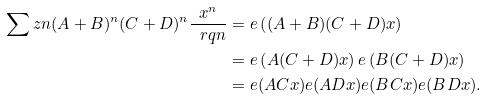<formula> <loc_0><loc_0><loc_500><loc_500>\sum z n ( A + B ) ^ { n } ( C + D ) ^ { n } \frac { x ^ { n } } { \ r q n } & = e \left ( ( A + B ) ( C + D ) x \right ) \\ & = e \left ( A ( C + D ) x \right ) e \left ( B ( C + D ) x \right ) \\ & = e ( A C x ) e ( A D x ) e ( B C x ) e ( B D x ) .</formula> 